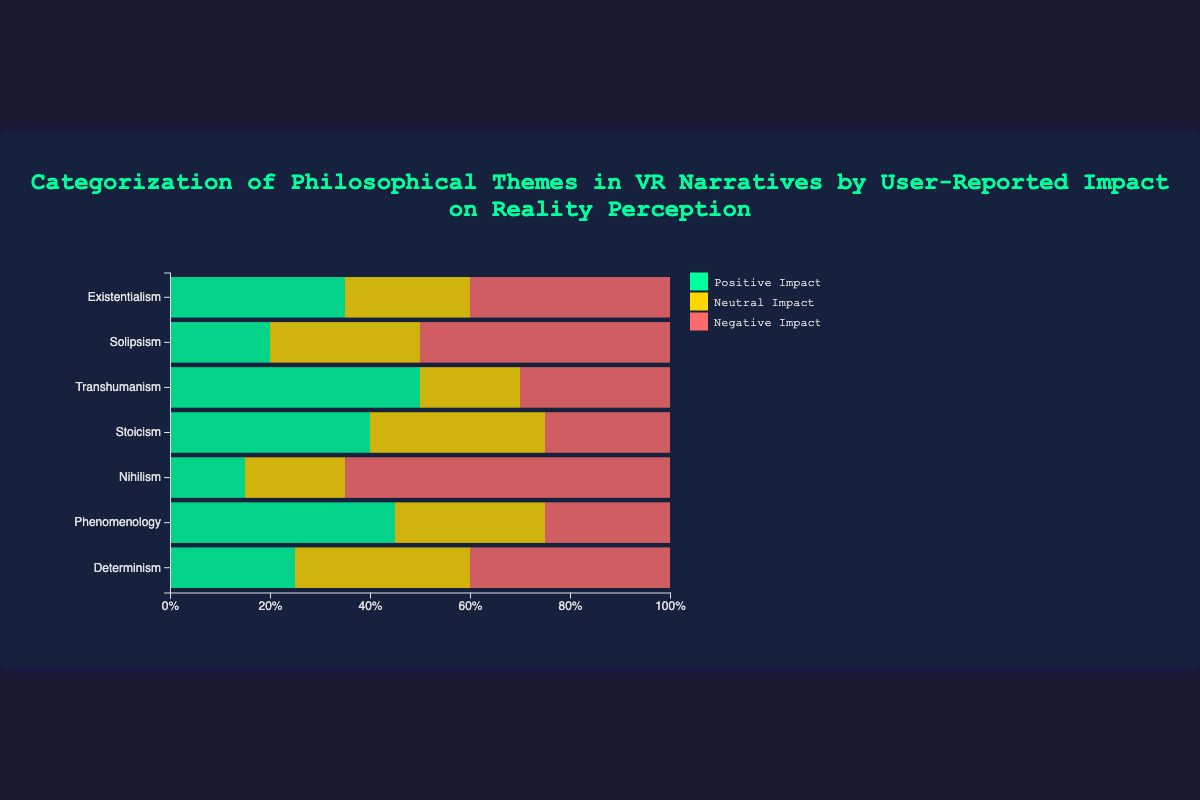What philosophical theme has the highest percentage of positive impact? First, look for the segment of the bar that represents a positive impact (usually colored) for each theme. Find the highest value among all themes. The highest positive impact segment is 50% for Transhumanism.
Answer: Transhumanism Which two philosophical themes have the same percentage of negative impact? Look for the negative impact segments for each theme and compare their values. Existentialism and Determinism both have a 40% negative impact.
Answer: Existentialism and Determinism What is the total percentage of neutral impact for Stoicism and Phenomenology combined? Check the neutral impact percentage for Stoicism (35%) and Phenomenology (30%). Add them together to get 35% + 30% = 65%.
Answer: 65% Which philosophical theme has the largest negative impact, and what is that percentage? Identify the theme with the largest segment for negative impact. Nihilism has the largest negative impact at 65%.
Answer: Nihilism, 65% Compare the sum of positive and neutral impacts for Existentialism and Solipsism. Which one is higher? Sum the positive and neutral impacts for Existentialism (35% + 25% = 60%) and Solipsism (20% + 30% = 50%). 60% is higher than 50%.
Answer: Existentialism In terms of positive impact, is Solipsism closer to Determinism or Stoicism? Check the positive impact for Solipsism (20%), Determinism (25%), and Stoicism (40%). Solipsism is closer to Determinism (25%) than Stoicism (40%).
Answer: Determinism Which philosophical theme shows the smallest neutral impact percentage? Identify which theme has the smallest segment for neutral impact. Transhumanism has the smallest neutral impact at 20%.
Answer: Transhumanism What is the difference in negative impact percentage between Transhumanism and Stoicism? Subtract the negative impact of Stoicism (25%) from that of Transhumanism (30%). The difference is 30% - 25% = 5%.
Answer: 5% Which philosophical themes have more than 40% negative impact? Check each theme’s negative impact percentage to see which ones are greater than 40%. Existentialism (40%), Solipsism (50%), Nihilism (65%), and Determinism (40%) meet this criteria.
Answer: Solipsism, Nihilism What is the average positive impact percentage across all themes? Sum all positive impact percentages (35%, 20%, 50%, 40%, 15%, 45%, 25%) which equals to 230%, and divide by the number of themes (7). The average is 230% / 7 ≈ 32.86%.
Answer: 32.86% 